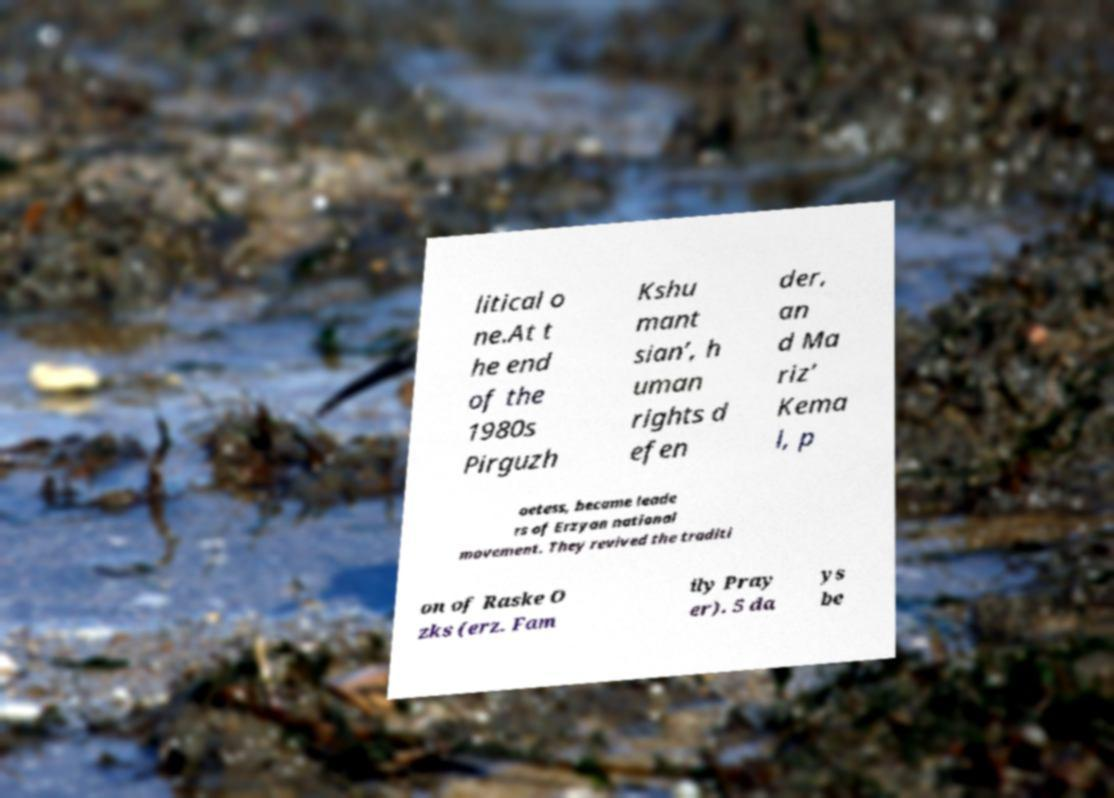Please identify and transcribe the text found in this image. litical o ne.At t he end of the 1980s Pirguzh Kshu mant sian’, h uman rights d efen der, an d Ma riz’ Kema l, p oetess, became leade rs of Erzyan national movement. They revived the traditi on of Raske O zks (erz. Fam ily Pray er). 5 da ys be 